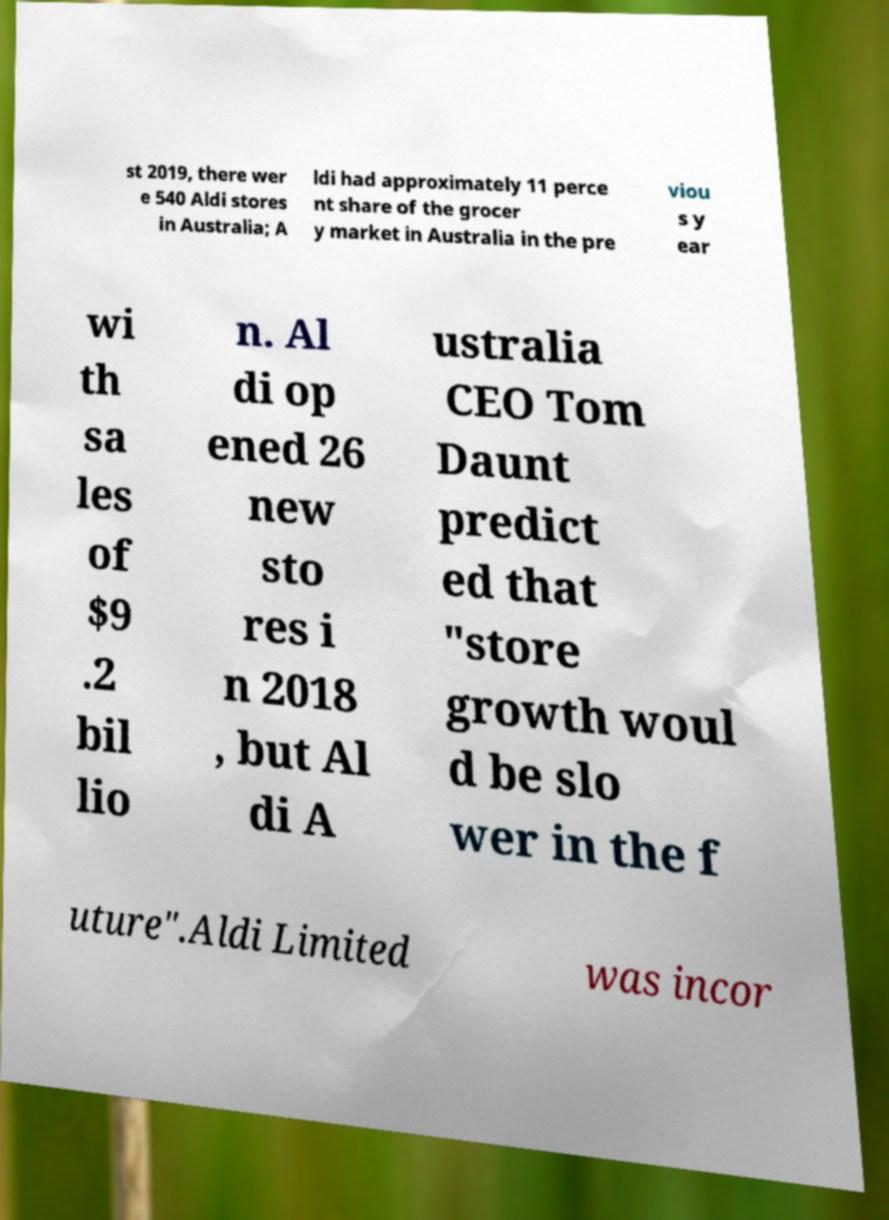I need the written content from this picture converted into text. Can you do that? st 2019, there wer e 540 Aldi stores in Australia; A ldi had approximately 11 perce nt share of the grocer y market in Australia in the pre viou s y ear wi th sa les of $9 .2 bil lio n. Al di op ened 26 new sto res i n 2018 , but Al di A ustralia CEO Tom Daunt predict ed that "store growth woul d be slo wer in the f uture".Aldi Limited was incor 